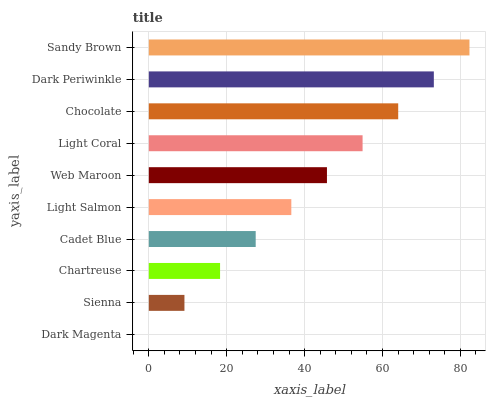Is Dark Magenta the minimum?
Answer yes or no. Yes. Is Sandy Brown the maximum?
Answer yes or no. Yes. Is Sienna the minimum?
Answer yes or no. No. Is Sienna the maximum?
Answer yes or no. No. Is Sienna greater than Dark Magenta?
Answer yes or no. Yes. Is Dark Magenta less than Sienna?
Answer yes or no. Yes. Is Dark Magenta greater than Sienna?
Answer yes or no. No. Is Sienna less than Dark Magenta?
Answer yes or no. No. Is Web Maroon the high median?
Answer yes or no. Yes. Is Light Salmon the low median?
Answer yes or no. Yes. Is Sandy Brown the high median?
Answer yes or no. No. Is Dark Magenta the low median?
Answer yes or no. No. 